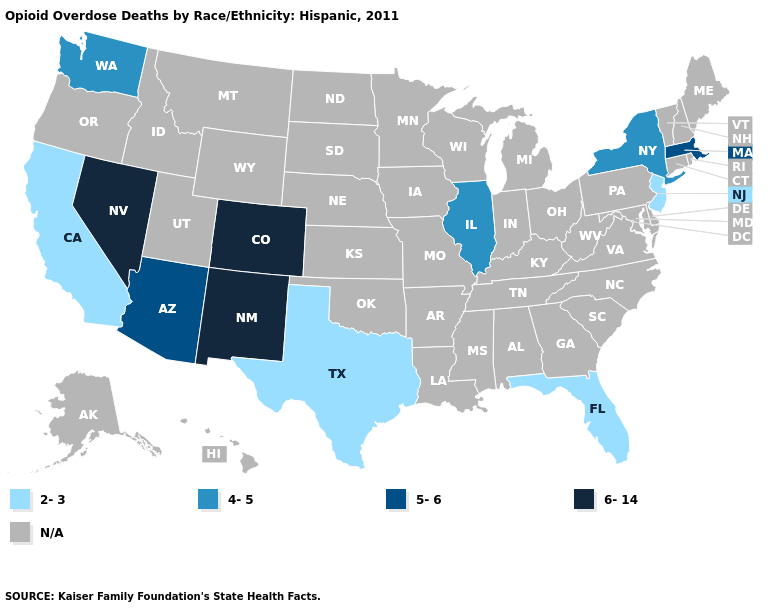Name the states that have a value in the range 5-6?
Write a very short answer. Arizona, Massachusetts. Name the states that have a value in the range 2-3?
Be succinct. California, Florida, New Jersey, Texas. What is the value of Missouri?
Keep it brief. N/A. Is the legend a continuous bar?
Concise answer only. No. Among the states that border Idaho , does Nevada have the highest value?
Be succinct. Yes. What is the value of Tennessee?
Answer briefly. N/A. Name the states that have a value in the range 4-5?
Concise answer only. Illinois, New York, Washington. What is the value of Indiana?
Quick response, please. N/A. What is the lowest value in states that border Wyoming?
Quick response, please. 6-14. What is the lowest value in the MidWest?
Write a very short answer. 4-5. Does Florida have the lowest value in the USA?
Concise answer only. Yes. How many symbols are there in the legend?
Be succinct. 5. What is the value of Missouri?
Give a very brief answer. N/A. 